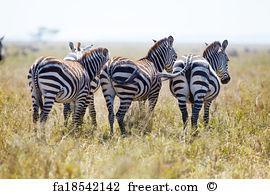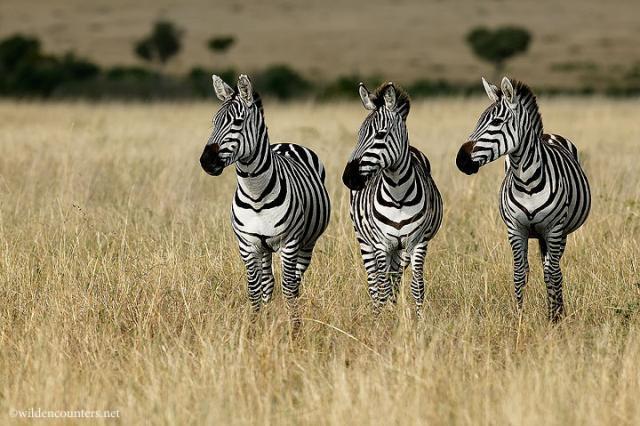The first image is the image on the left, the second image is the image on the right. Assess this claim about the two images: "The left and right image contains the same number of zebras facing forwards and backwards.". Correct or not? Answer yes or no. Yes. The first image is the image on the left, the second image is the image on the right. Analyze the images presented: Is the assertion "Each image contains exactly three zebras, and one group of three zebras is turned away from the camera, with their rears showing." valid? Answer yes or no. Yes. 